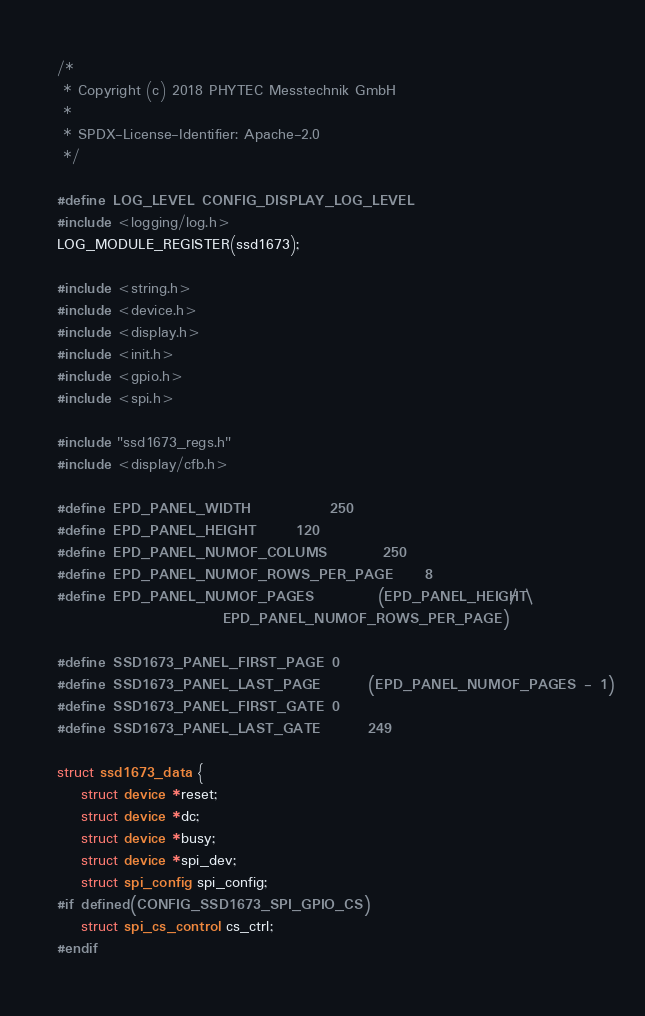Convert code to text. <code><loc_0><loc_0><loc_500><loc_500><_C_>/*
 * Copyright (c) 2018 PHYTEC Messtechnik GmbH
 *
 * SPDX-License-Identifier: Apache-2.0
 */

#define LOG_LEVEL CONFIG_DISPLAY_LOG_LEVEL
#include <logging/log.h>
LOG_MODULE_REGISTER(ssd1673);

#include <string.h>
#include <device.h>
#include <display.h>
#include <init.h>
#include <gpio.h>
#include <spi.h>

#include "ssd1673_regs.h"
#include <display/cfb.h>

#define EPD_PANEL_WIDTH			250
#define EPD_PANEL_HEIGHT		120
#define EPD_PANEL_NUMOF_COLUMS		250
#define EPD_PANEL_NUMOF_ROWS_PER_PAGE	8
#define EPD_PANEL_NUMOF_PAGES		(EPD_PANEL_HEIGHT / \
					 EPD_PANEL_NUMOF_ROWS_PER_PAGE)

#define SSD1673_PANEL_FIRST_PAGE	0
#define SSD1673_PANEL_LAST_PAGE		(EPD_PANEL_NUMOF_PAGES - 1)
#define SSD1673_PANEL_FIRST_GATE	0
#define SSD1673_PANEL_LAST_GATE		249

struct ssd1673_data {
	struct device *reset;
	struct device *dc;
	struct device *busy;
	struct device *spi_dev;
	struct spi_config spi_config;
#if defined(CONFIG_SSD1673_SPI_GPIO_CS)
	struct spi_cs_control cs_ctrl;
#endif</code> 